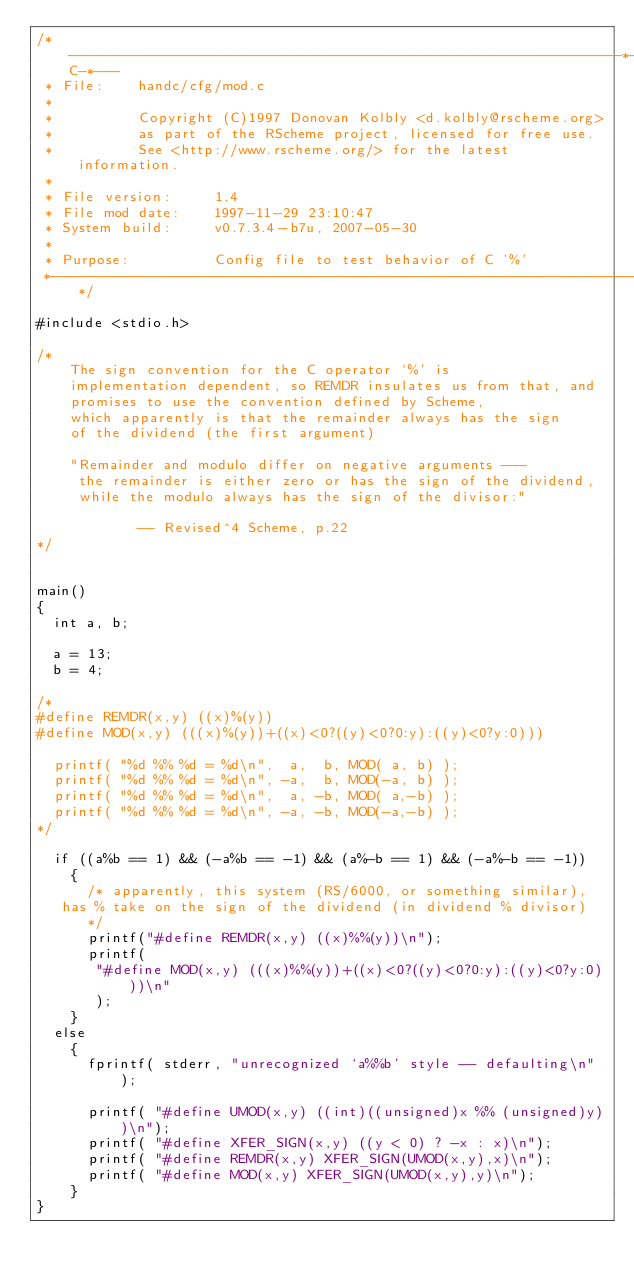<code> <loc_0><loc_0><loc_500><loc_500><_C_>/*-----------------------------------------------------------------*-C-*---
 * File:    handc/cfg/mod.c
 *
 *          Copyright (C)1997 Donovan Kolbly <d.kolbly@rscheme.org>
 *          as part of the RScheme project, licensed for free use.
 *          See <http://www.rscheme.org/> for the latest information.
 *
 * File version:     1.4
 * File mod date:    1997-11-29 23:10:47
 * System build:     v0.7.3.4-b7u, 2007-05-30
 *
 * Purpose:          Config file to test behavior of C '%'
 *------------------------------------------------------------------------*/

#include <stdio.h>

/*
    The sign convention for the C operator `%' is
    implementation dependent, so REMDR insulates us from that, and
    promises to use the convention defined by Scheme,
    which apparently is that the remainder always has the sign
    of the dividend (the first argument)

    "Remainder and modulo differ on negative arguments ---
     the remainder is either zero or has the sign of the dividend,
     while the modulo always has the sign of the divisor:"
    
				    -- Revised^4 Scheme, p.22
*/


main()
{
  int a, b;

  a = 13;
  b = 4;

/*
#define REMDR(x,y) ((x)%(y))
#define MOD(x,y) (((x)%(y))+((x)<0?((y)<0?0:y):((y)<0?y:0)))

  printf( "%d %% %d = %d\n",  a,  b, MOD( a, b) );
  printf( "%d %% %d = %d\n", -a,  b, MOD(-a, b) ); 
  printf( "%d %% %d = %d\n",  a, -b, MOD( a,-b) ); 
  printf( "%d %% %d = %d\n", -a, -b, MOD(-a,-b) ); 
*/

  if ((a%b == 1) && (-a%b == -1) && (a%-b == 1) && (-a%-b == -1))
    {
      /* apparently, this system (RS/6000, or something similar),
	 has % take on the sign of the dividend (in dividend % divisor)
      */
      printf("#define REMDR(x,y) ((x)%%(y))\n");
      printf( 
	     "#define MOD(x,y) (((x)%%(y))+((x)<0?((y)<0?0:y):((y)<0?y:0)))\n"
	     );
    }
  else
    {
      fprintf( stderr, "unrecognized `a%%b' style -- defaulting\n" );
  
      printf( "#define UMOD(x,y) ((int)((unsigned)x %% (unsigned)y))\n");
      printf( "#define XFER_SIGN(x,y) ((y < 0) ? -x : x)\n");
      printf( "#define REMDR(x,y) XFER_SIGN(UMOD(x,y),x)\n");
      printf( "#define MOD(x,y) XFER_SIGN(UMOD(x,y),y)\n");
    }
}
</code> 